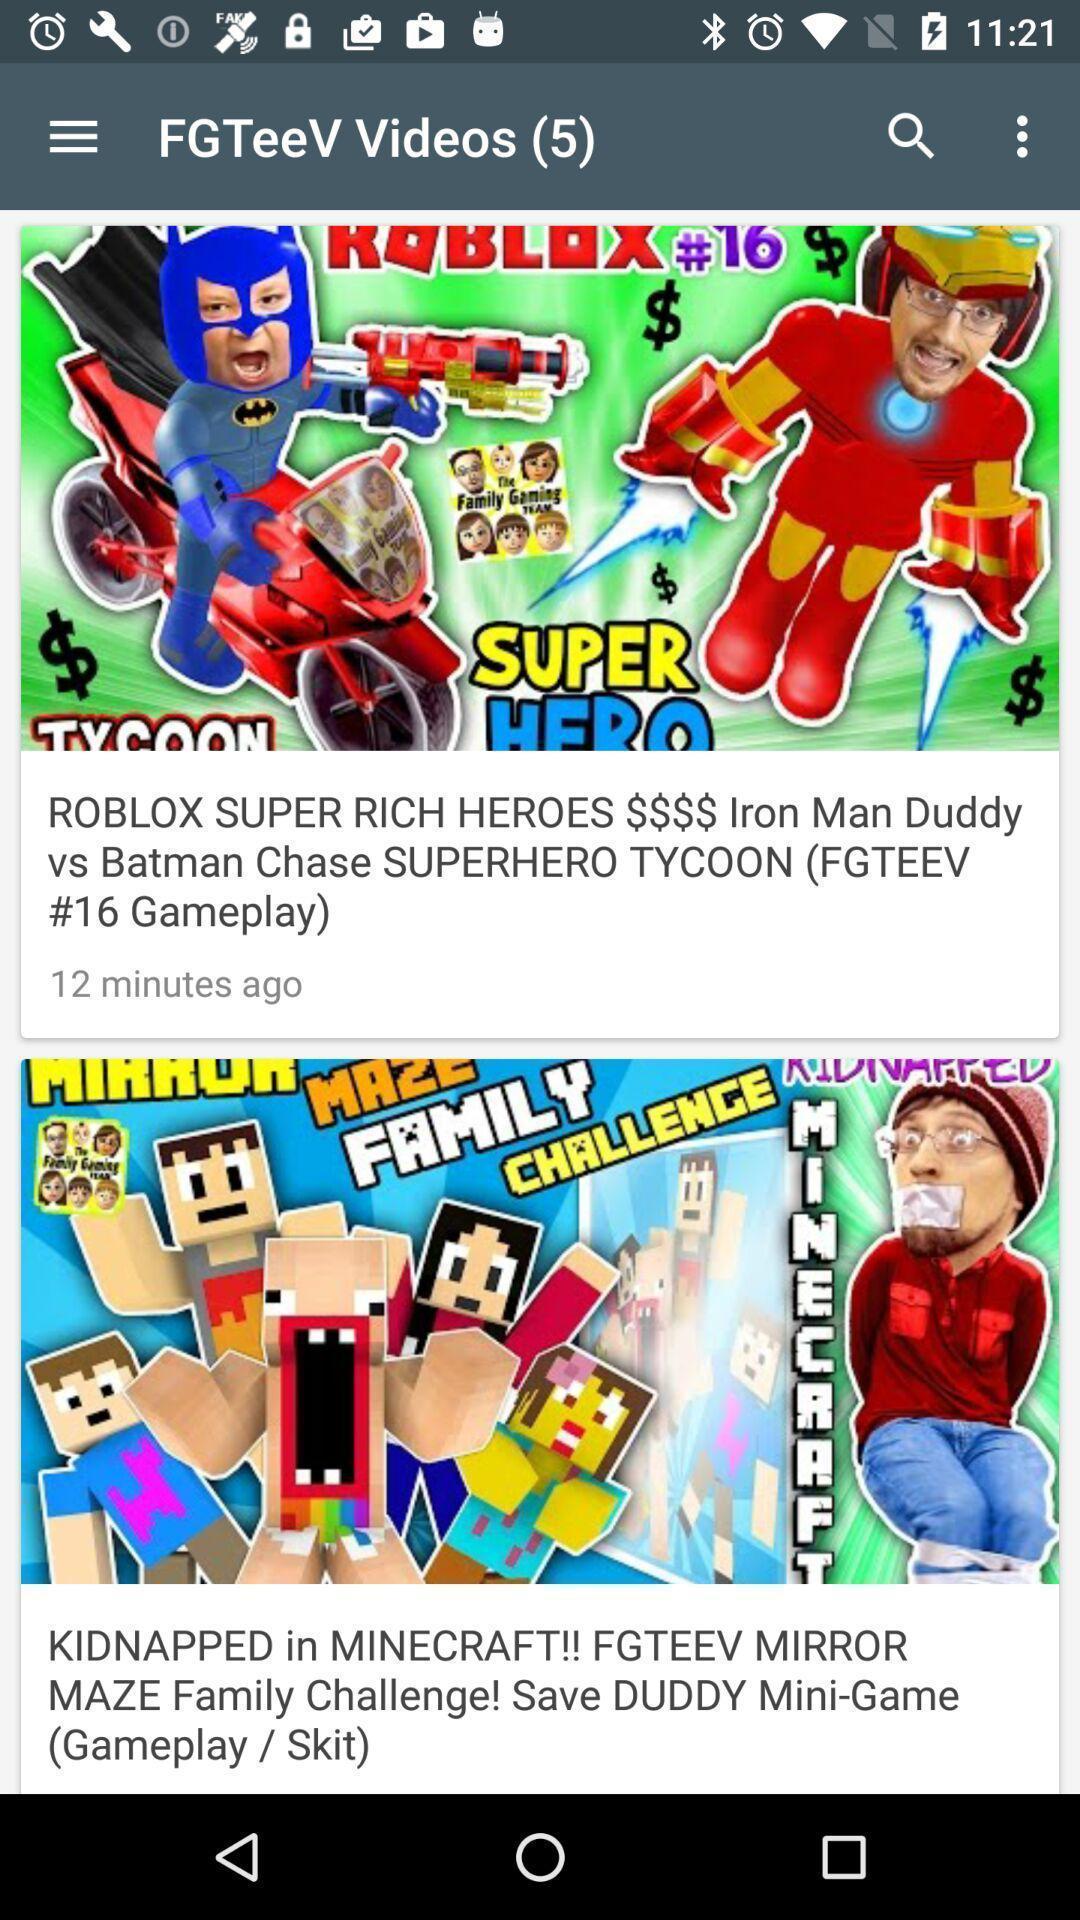Summarize the main components in this picture. Page showing top videos from kids collection. 